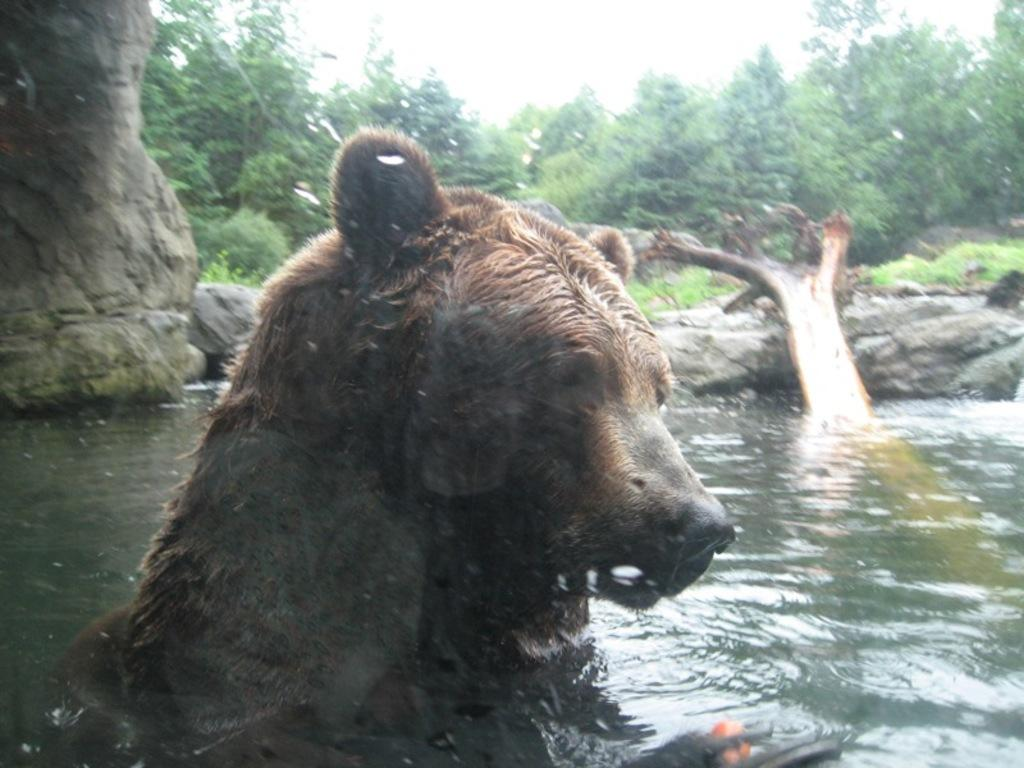What animal is in the water in the image? There is a bear in the water in the image. What type of object can be seen in the image? There is a wooden log in the image. What natural elements are present in the image? Stones, trees, grass, and the sky are visible in the image. How many potatoes can be seen in the image? There are no potatoes present in the image. What type of crowd is visible in the image? There is no crowd visible in the image; it features a bear in the water, a wooden log, stones, trees, grass, and the sky. 